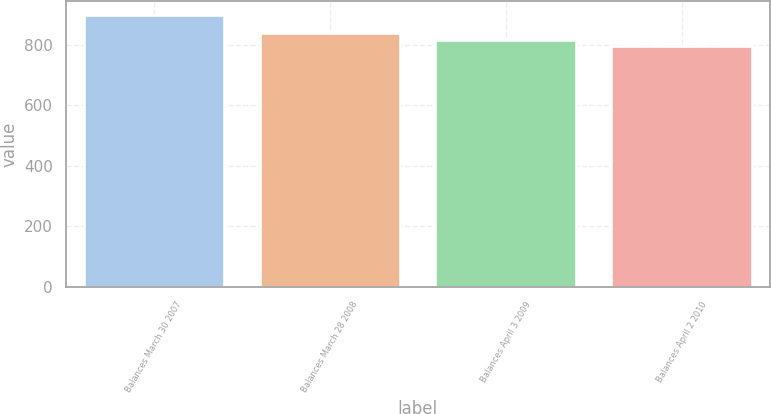Convert chart. <chart><loc_0><loc_0><loc_500><loc_500><bar_chart><fcel>Balances March 30 2007<fcel>Balances March 28 2008<fcel>Balances April 3 2009<fcel>Balances April 2 2010<nl><fcel>899<fcel>839<fcel>817<fcel>798<nl></chart> 